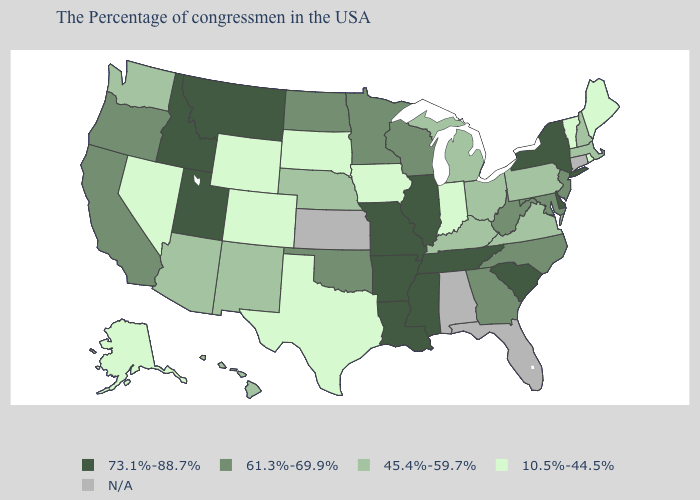Among the states that border Connecticut , which have the lowest value?
Short answer required. Rhode Island. Name the states that have a value in the range 45.4%-59.7%?
Answer briefly. Massachusetts, New Hampshire, Pennsylvania, Virginia, Ohio, Michigan, Kentucky, Nebraska, New Mexico, Arizona, Washington, Hawaii. What is the value of Alaska?
Give a very brief answer. 10.5%-44.5%. Which states have the highest value in the USA?
Quick response, please. New York, Delaware, South Carolina, Tennessee, Illinois, Mississippi, Louisiana, Missouri, Arkansas, Utah, Montana, Idaho. Name the states that have a value in the range N/A?
Keep it brief. Connecticut, Florida, Alabama, Kansas. What is the value of Missouri?
Short answer required. 73.1%-88.7%. What is the value of Wyoming?
Short answer required. 10.5%-44.5%. Name the states that have a value in the range 61.3%-69.9%?
Quick response, please. New Jersey, Maryland, North Carolina, West Virginia, Georgia, Wisconsin, Minnesota, Oklahoma, North Dakota, California, Oregon. Does Nebraska have the highest value in the USA?
Answer briefly. No. Name the states that have a value in the range 10.5%-44.5%?
Answer briefly. Maine, Rhode Island, Vermont, Indiana, Iowa, Texas, South Dakota, Wyoming, Colorado, Nevada, Alaska. Which states hav the highest value in the MidWest?
Quick response, please. Illinois, Missouri. What is the highest value in the West ?
Write a very short answer. 73.1%-88.7%. What is the highest value in the USA?
Short answer required. 73.1%-88.7%. 